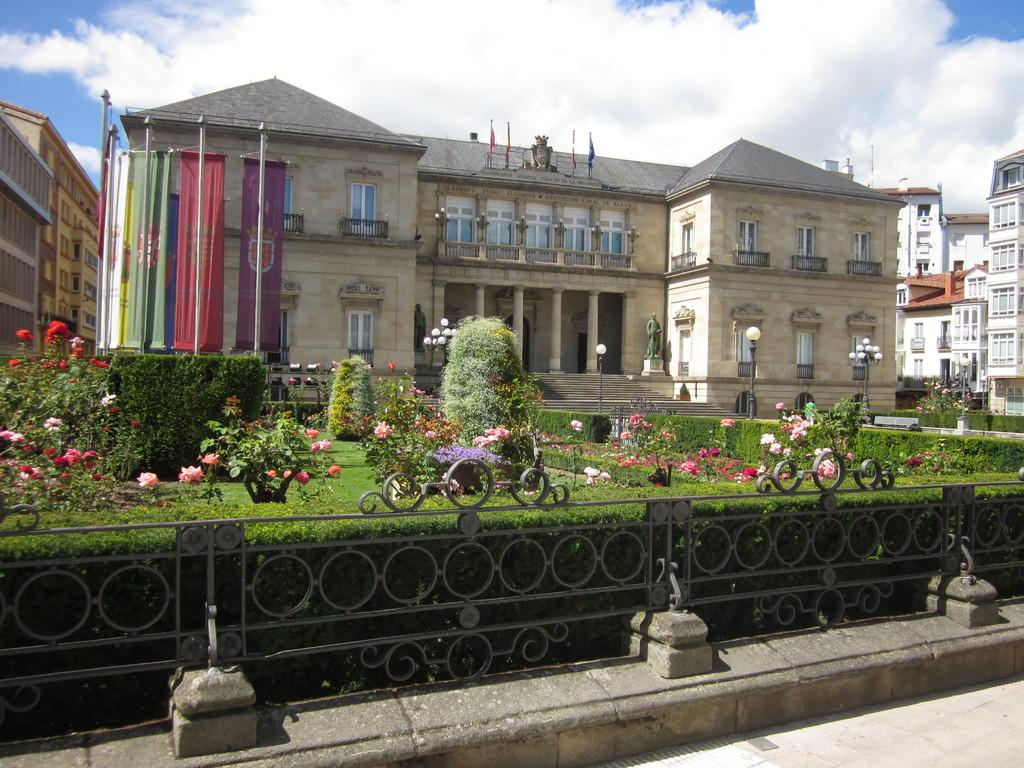What type of structures can be seen in the image? There are buildings in the image. What is attached to the flag posts? Flags are attached to the flag posts in the image. What type of vegetation is present in the image? There are plants, flowers, and bushes in the image. What is visible on the ground in the image? The ground is visible in the image. What type of barrier can be seen in the image? There is a fence in the image. What architectural feature is present in the image? There are stairs in the image. What type of poles are visible in the image? There are street poles in the image. What type of lighting is present in the image? There are street lights in the image. What is visible in the sky in the image? The sky is visible in the image, and there are clouds present. What is the rate of the birds flying in the image? There are no birds present in the image, so there is no rate to determine. What type of jeans are the people wearing in the image? There are no people visible in the image, so it is impossible to determine what type of jeans they might be wearing. 